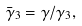Convert formula to latex. <formula><loc_0><loc_0><loc_500><loc_500>\bar { \gamma } _ { 3 } = \gamma / \gamma _ { 3 } ,</formula> 